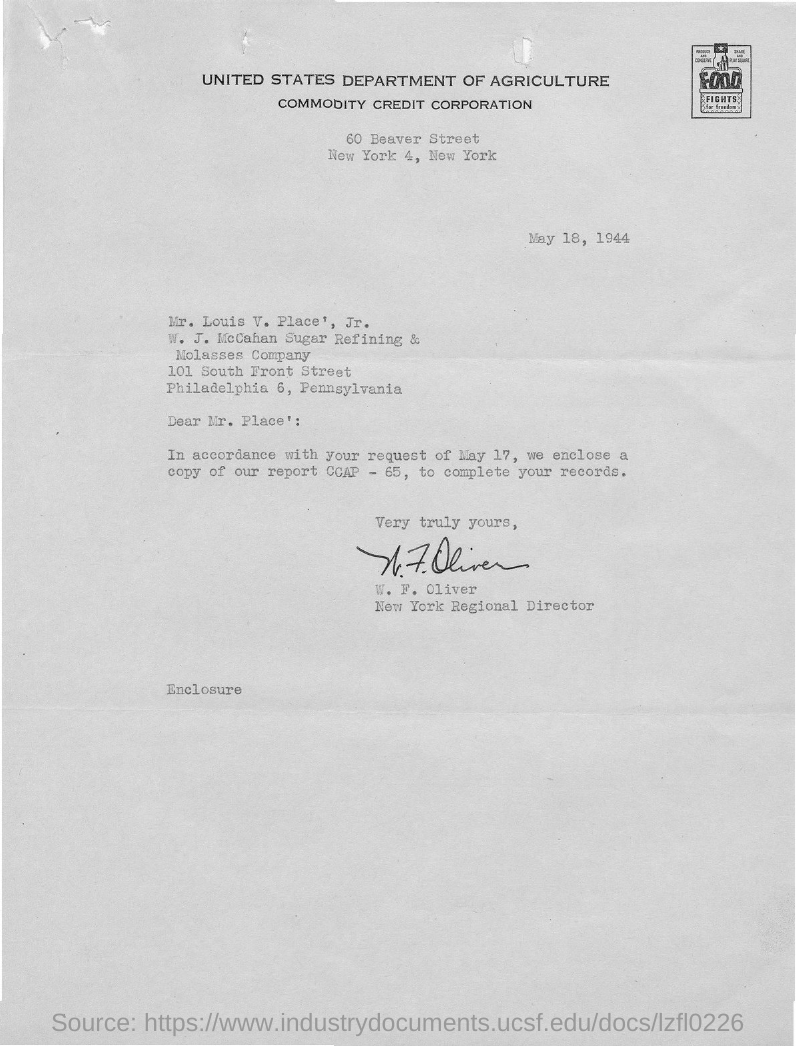Specify some key components in this picture. What copy is enclosed? Report CCAP - 65..." is a question asking for information about the enclosed report. The Commodity Credit Corporation is located in New York. The letter is from W. F. Oliver. The letter is addressed to Mr. Louis V. Place, Jr. Louis V. is from the W. J. McCahan sugar refining & molasses company. 